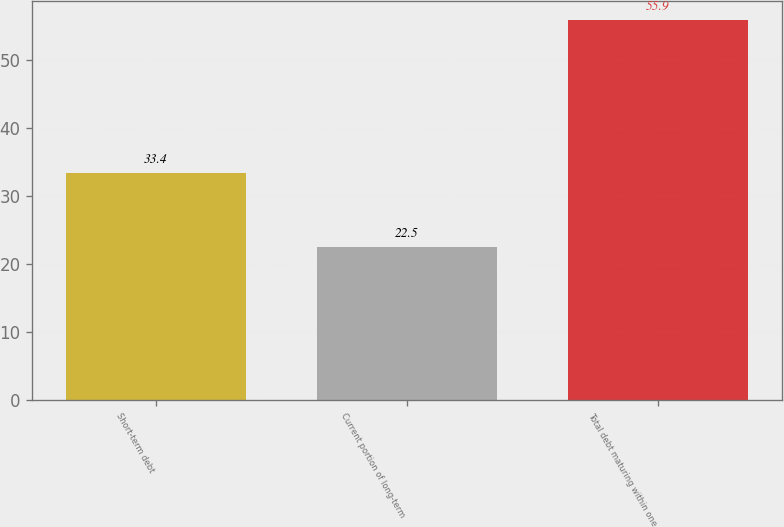Convert chart. <chart><loc_0><loc_0><loc_500><loc_500><bar_chart><fcel>Short-term debt<fcel>Current portion of long-term<fcel>Total debt maturing within one<nl><fcel>33.4<fcel>22.5<fcel>55.9<nl></chart> 